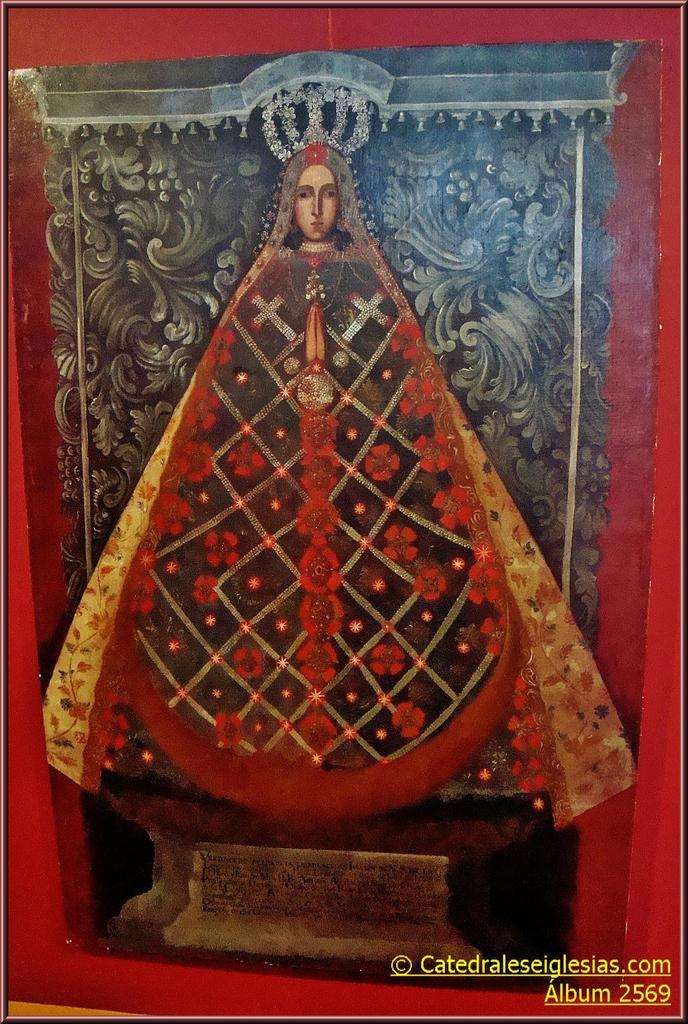What is the main subject of the image? There is a person in the image. What is the person wearing in the image? The person is wearing a costume with different colors. Can you describe the background of the image? The background of the image includes grey, black, and red colors. What type of degree can be seen hanging on the wall in the image? There is no degree or wall present in the image; it features a person wearing a costume in a background with grey, black, and red colors. 